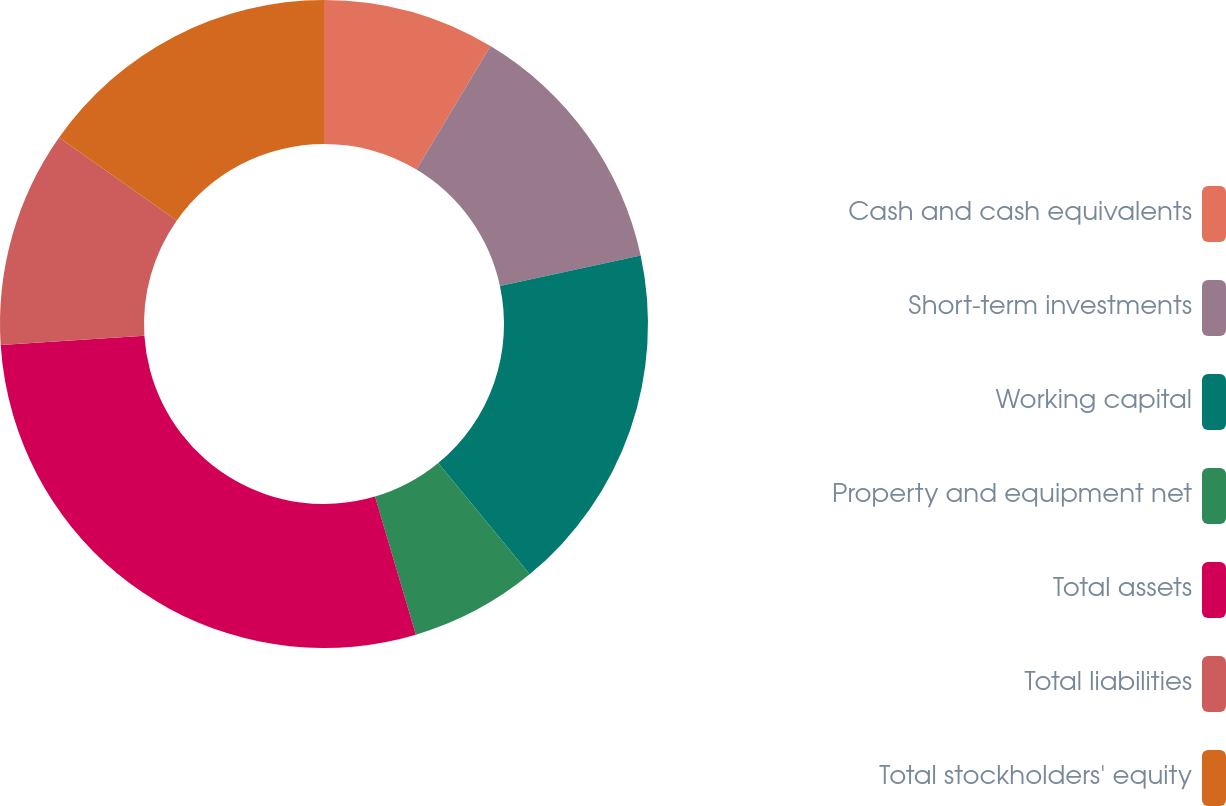Convert chart to OTSL. <chart><loc_0><loc_0><loc_500><loc_500><pie_chart><fcel>Cash and cash equivalents<fcel>Short-term investments<fcel>Working capital<fcel>Property and equipment net<fcel>Total assets<fcel>Total liabilities<fcel>Total stockholders' equity<nl><fcel>8.59%<fcel>13.02%<fcel>17.45%<fcel>6.37%<fcel>28.54%<fcel>10.8%<fcel>15.24%<nl></chart> 